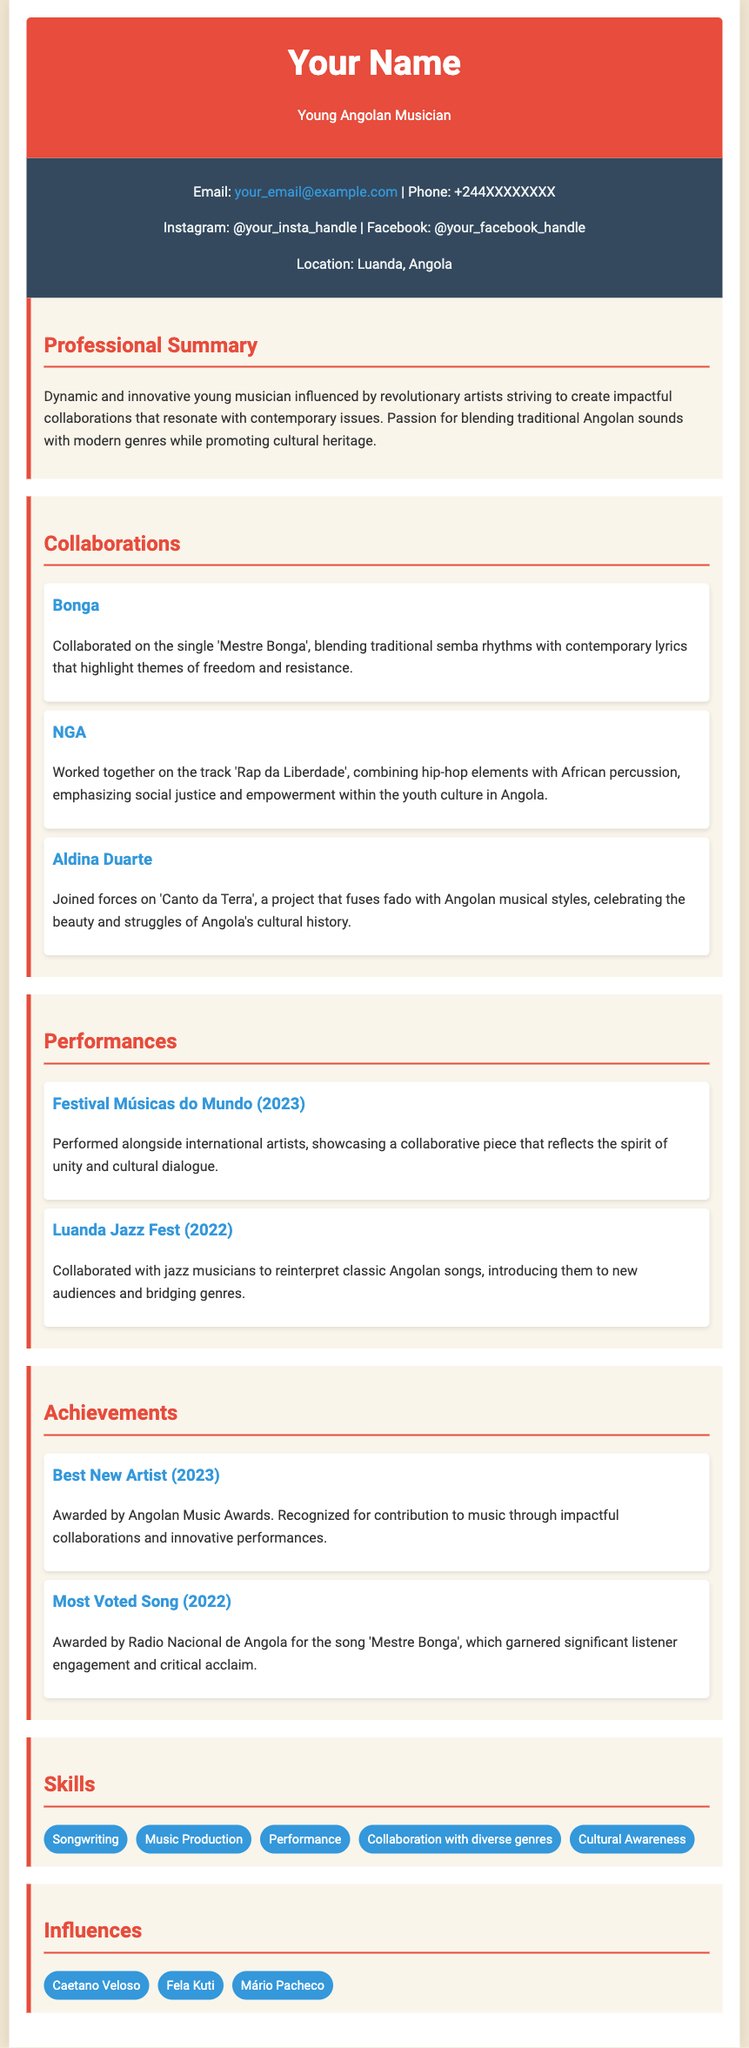What is the name of the musician? The document states the musician's name as "Your Name".
Answer: Your Name What year won the Best New Artist award? The document indicates that the Best New Artist award was received in the year 2023.
Answer: 2023 Which collaboration emphasizes social justice? The collaboration with NGA on the track 'Rap da Liberdade' emphasizes social justice.
Answer: NGA What festival took place in 2023? The document mentions the Festival Músicas do Mundo was held in 2023.
Answer: Festival Músicas do Mundo Who collaborated on the song 'Mestre Bonga'? The collaboration for the song 'Mestre Bonga' was with Bonga.
Answer: Bonga What is the main focus of the professional summary? The professional summary emphasizes creating impactful collaborations that resonate with contemporary issues.
Answer: Impactful collaborations Which genre is fused with fado in the collaboration? The collaboration with Aldina Duarte fuses fado with Angolan musical styles.
Answer: Angolan musical styles What skill is specifically mentioned regarding collaboration? The document lists "Collaboration with diverse genres" as a specific skill.
Answer: Collaboration with diverse genres Which artist is mentioned as an influence? Caetano Veloso is mentioned as an influence in the document.
Answer: Caetano Veloso What was awarded in 2022 by Radio Nacional de Angola? The song 'Mestre Bonga' was awarded as the Most Voted Song in 2022.
Answer: Most Voted Song 